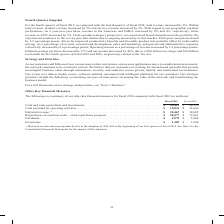According to Cisco Systems's financial document, Why did deferred revenue decrease? due to the adoption of ASC 606 in the beginning of our first quarter of fiscal 2019.. The document states: "(1) Deferred revenue decreased primarily due to the adoption of ASC 606 in the beginning of our first quarter of fiscal 2019. See Note 2 to the Consol..." Also, What was the deferred revenue in 2019? According to the financial document, 18,467 (in millions). The relevant text states: "ties . $ 15,831 $ 13,666 Deferred revenue (1) . $ 18,467 $ 19,685 Repurchases of common stock—stock repurchase program . $ 20,577 $ 17,661 Dividends . $ 5,9..." Also, What were the dividends in 2018? According to the financial document, 5,968 (in millions). The relevant text states: "program . $ 20,577 $ 17,661 Dividends . $ 5,979 $ 5,968 Inventories . $ 1,383 $ 1,846..." Also, can you calculate: What was the change in inventories between 2018 and 2019? Based on the calculation: 1,383-1,846, the result is -463 (in millions). This is based on the information: "7,661 Dividends . $ 5,979 $ 5,968 Inventories . $ 1,383 $ 1,846 vidends . $ 5,979 $ 5,968 Inventories . $ 1,383 $ 1,846..." The key data points involved are: 1,383, 1,846. Also, can you calculate: What was the change in Cash provided by operating activities between 2018 and 2019? Based on the calculation: 15,831-13,666, the result is 2165 (in millions). This is based on the information: "46,548 Cash provided by operating activities . $ 15,831 $ 13,666 Deferred revenue (1) . $ 18,467 $ 19,685 Repurchases of common stock—stock repurchase prog ash provided by operating activities . $ 15,..." The key data points involved are: 13,666, 15,831. Also, can you calculate: What was the percentage change in deferred revenue between 2018 and 2019? To answer this question, I need to perform calculations using the financial data. The calculation is: (18,467-19,685)/19,685, which equals -6.19 (percentage). This is based on the information: "15,831 $ 13,666 Deferred revenue (1) . $ 18,467 $ 19,685 Repurchases of common stock—stock repurchase program . $ 20,577 $ 17,661 Dividends . $ 5,979 $ 5,96 ties . $ 15,831 $ 13,666 Deferred revenue (..." The key data points involved are: 18,467, 19,685. 